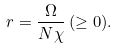Convert formula to latex. <formula><loc_0><loc_0><loc_500><loc_500>r = \frac { \Omega } { N \chi } \, ( \geq 0 ) .</formula> 